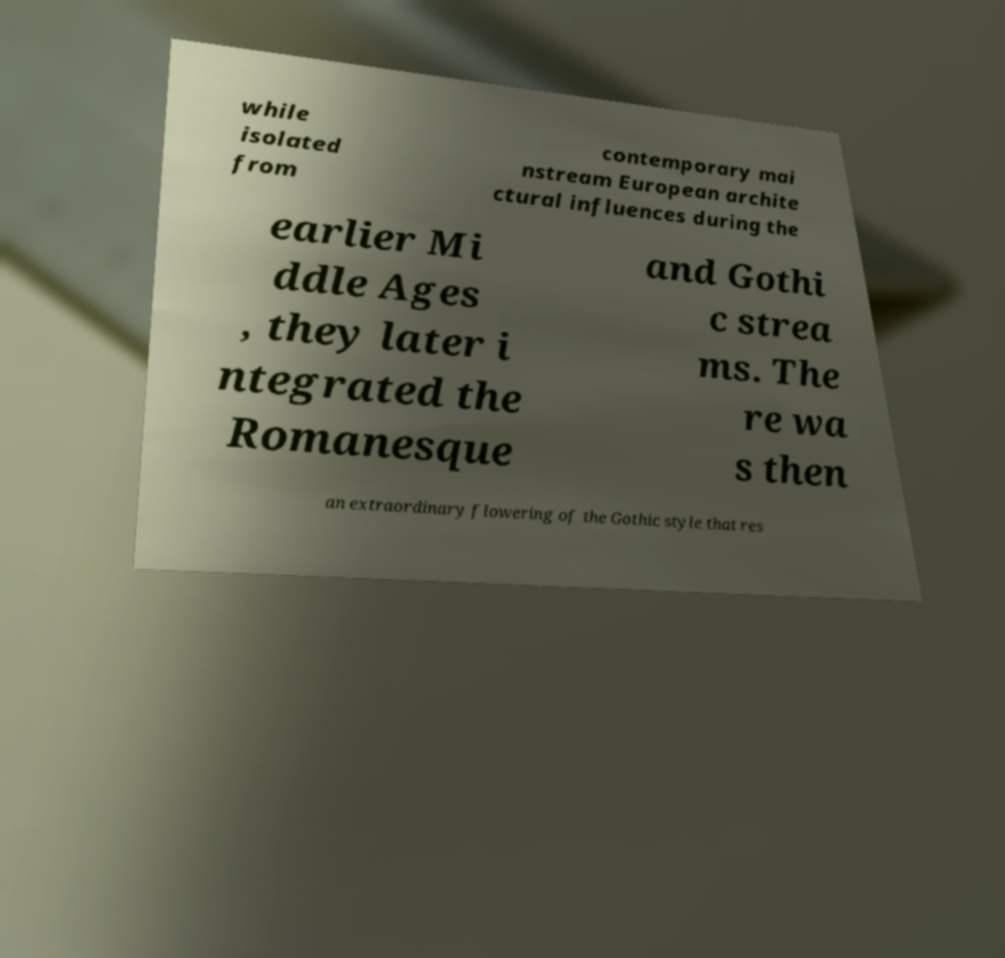Could you extract and type out the text from this image? while isolated from contemporary mai nstream European archite ctural influences during the earlier Mi ddle Ages , they later i ntegrated the Romanesque and Gothi c strea ms. The re wa s then an extraordinary flowering of the Gothic style that res 